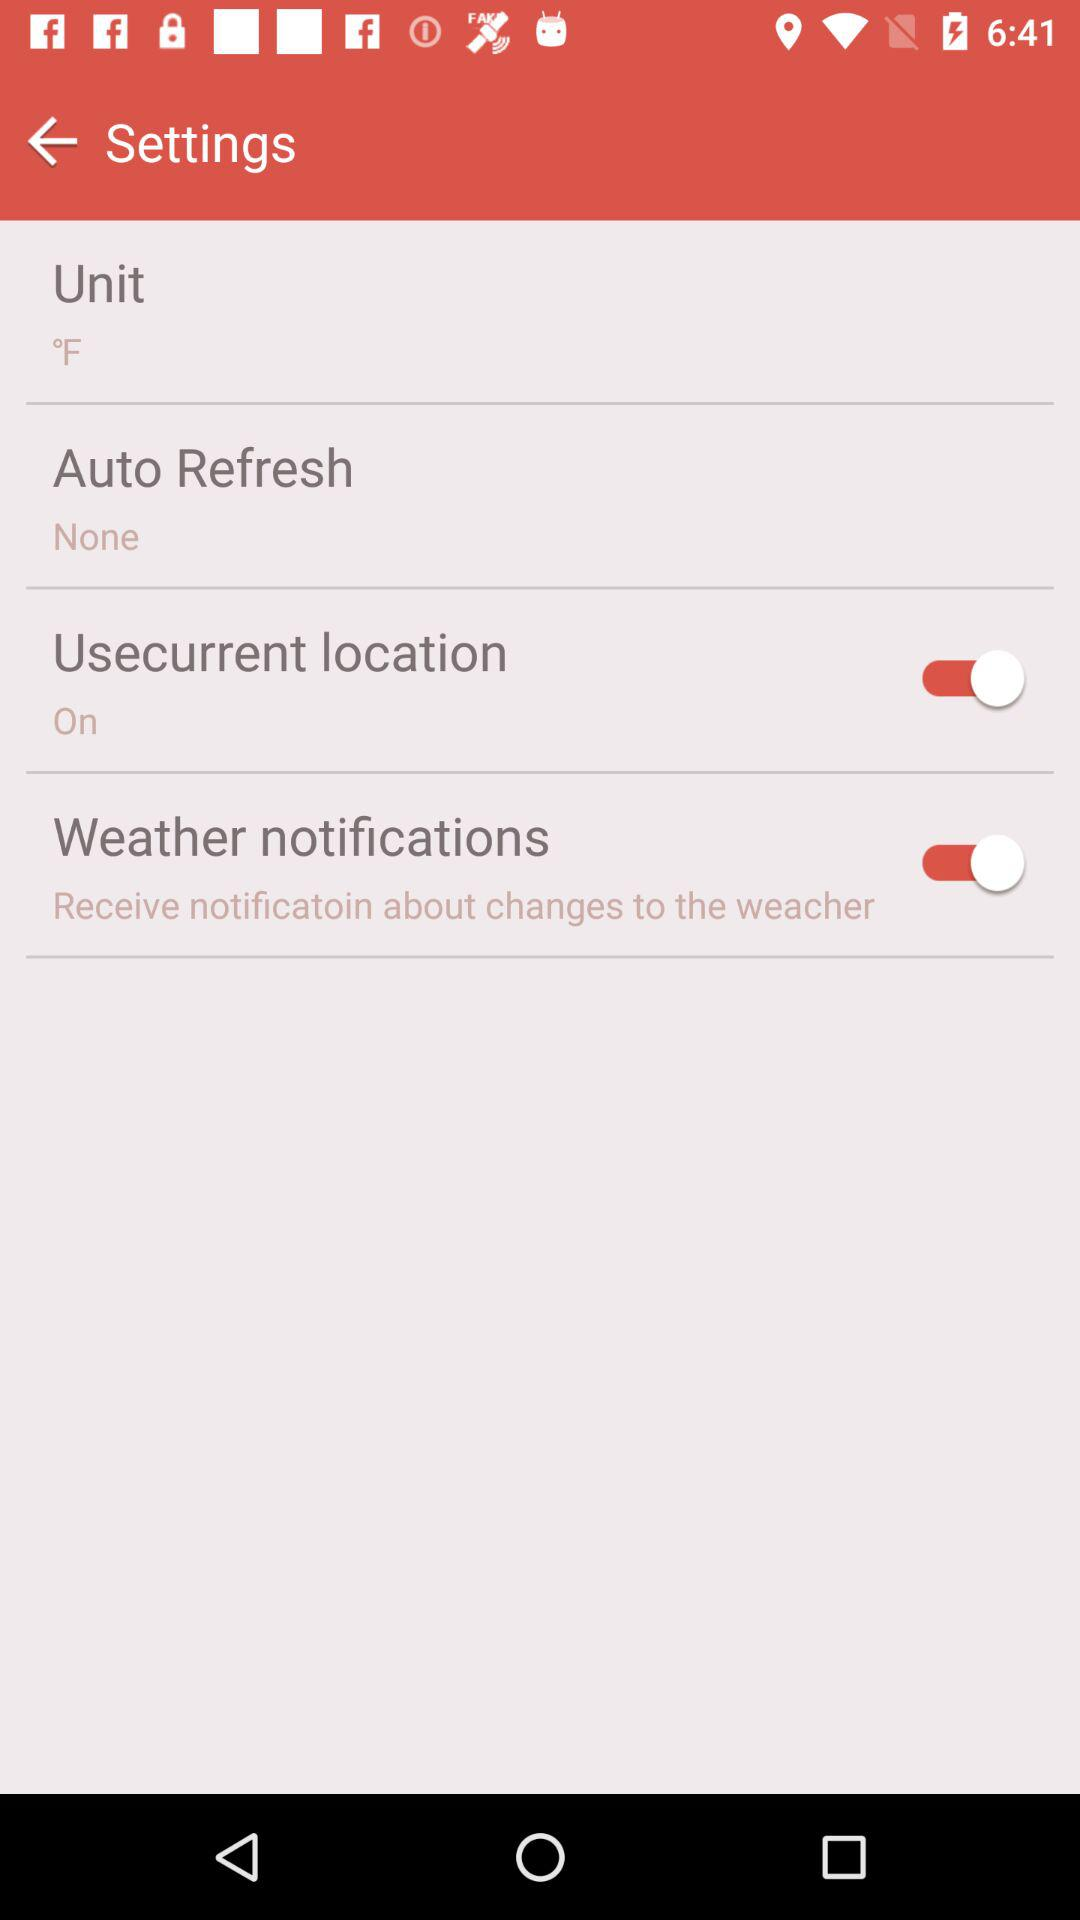How many switch elements are there in the settings menu?
Answer the question using a single word or phrase. 2 